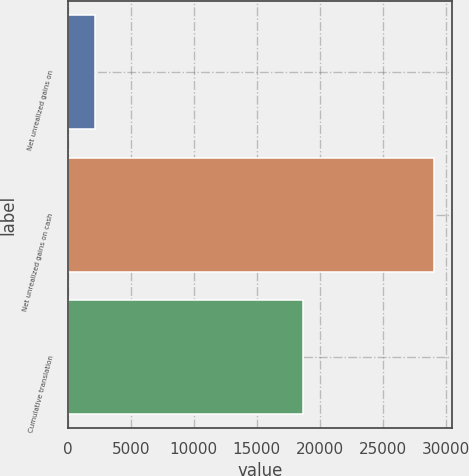<chart> <loc_0><loc_0><loc_500><loc_500><bar_chart><fcel>Net unrealized gains on<fcel>Net unrealized gains on cash<fcel>Cumulative translation<nl><fcel>2152<fcel>29079<fcel>18674<nl></chart> 